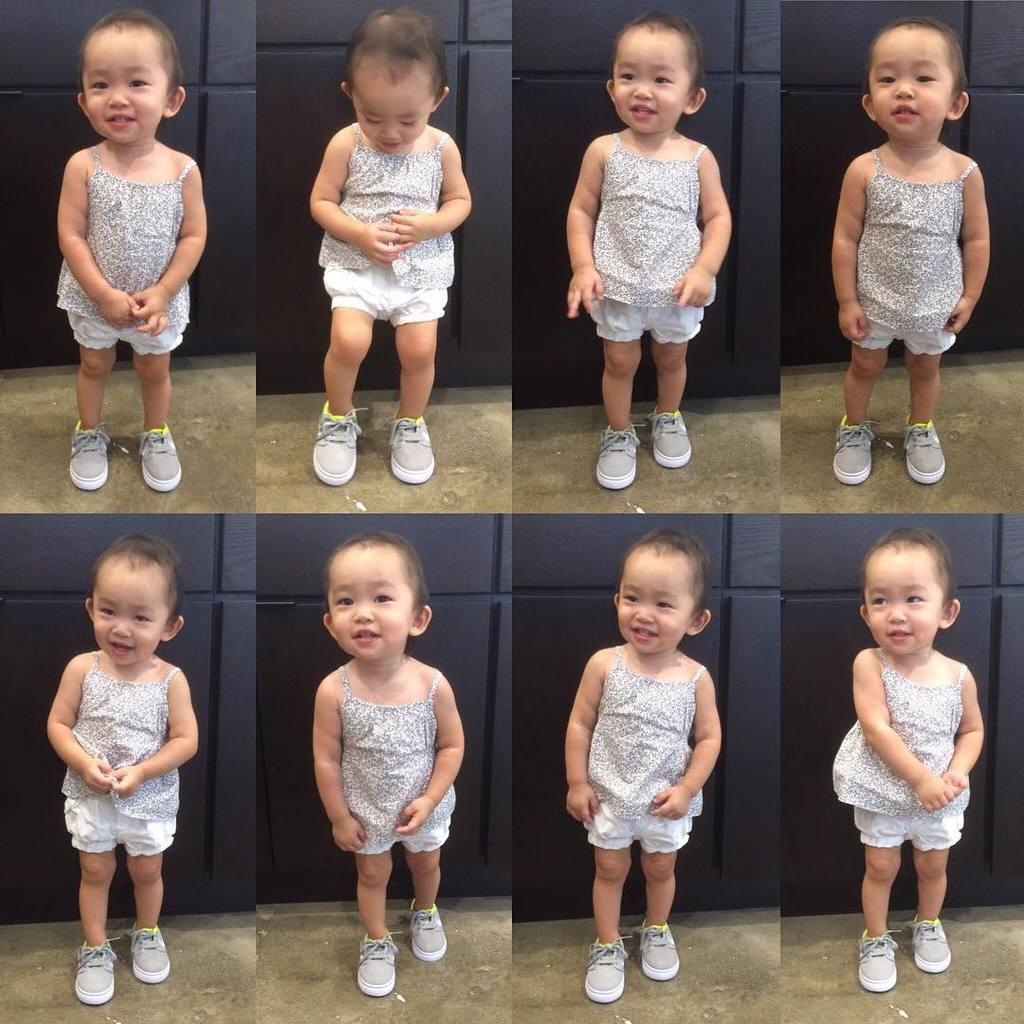What type of artwork is depicted in the image? The image is a collage. What subject is featured in the collage? The collage features a little girl. How many planes are visible in the image? There are no planes visible in the image, as it is a collage featuring a little girl. What type of glove is being exchanged in the image? There is no glove or exchange present in the image; it features a little girl in a collage. 